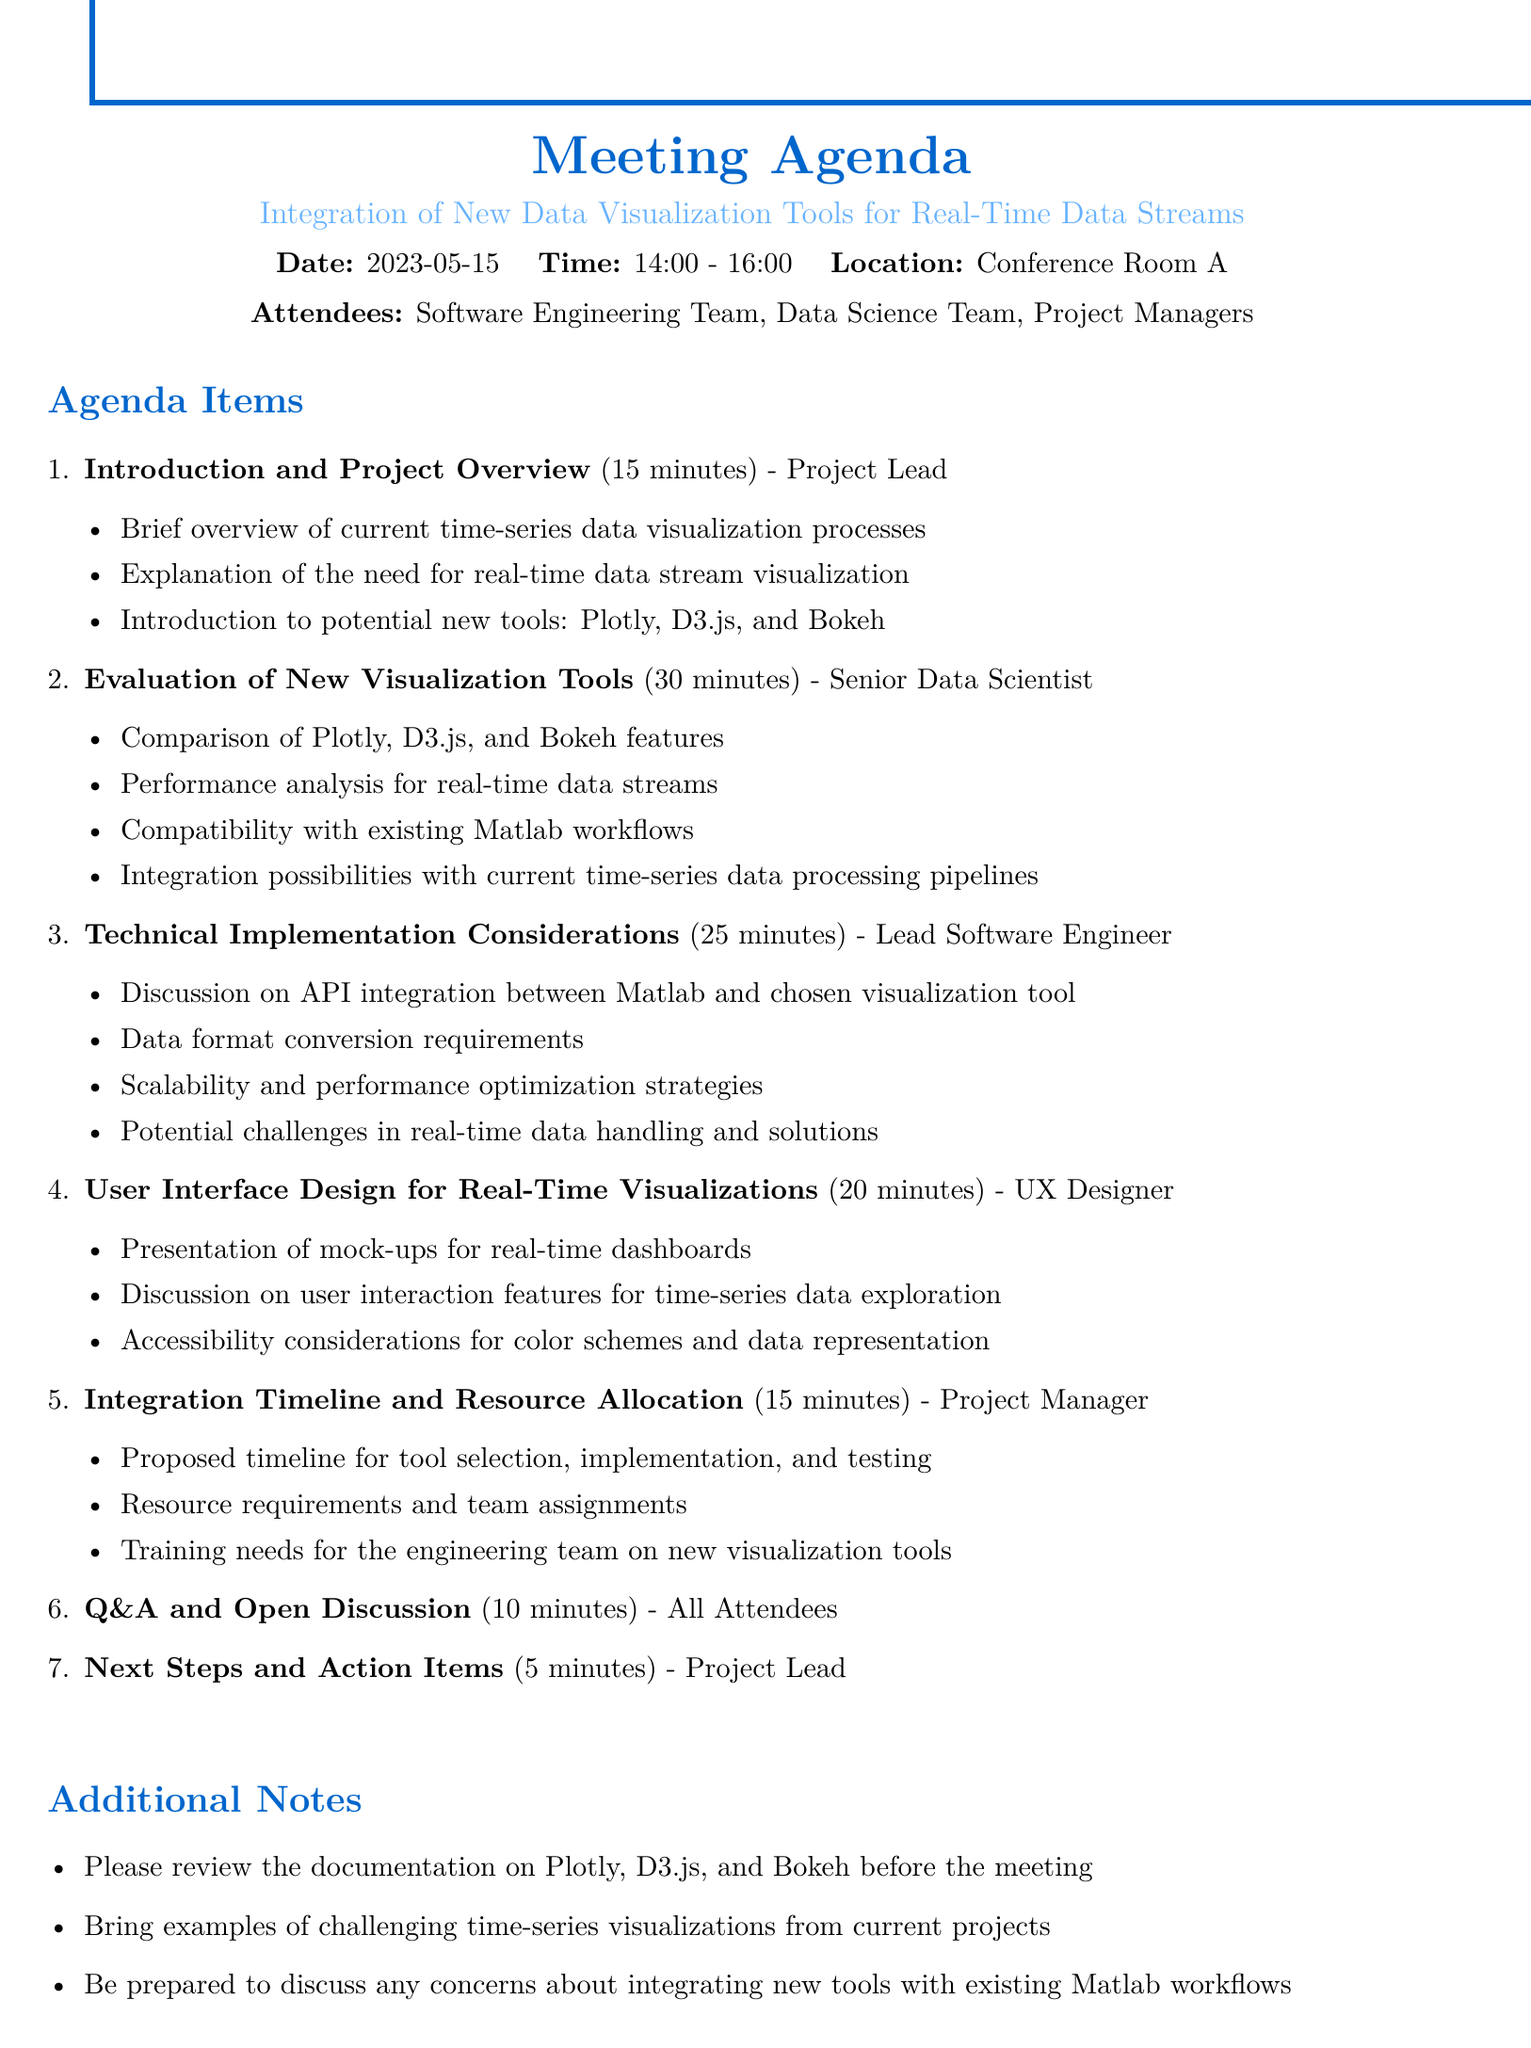What is the meeting date? The date of the meeting is specifically mentioned in the document as May 15, 2023.
Answer: May 15, 2023 Who is the presenter for the "Technical Implementation Considerations" topic? The document lists the presenter for the specific agenda item as the Lead Software Engineer.
Answer: Lead Software Engineer How long is the "Evaluation of New Visualization Tools" session? The duration for this session is indicated in the agenda, which is thirty minutes.
Answer: 30 minutes What is one of the proposed tools for real-time data stream visualization? The document includes potential tools, mentioning Plotly, D3.js, and Bokeh as examples.
Answer: Plotly What section discusses user interaction features? The section focused on user interaction features relates to the "User Interface Design for Real-Time Visualizations" agenda topic.
Answer: User Interface Design for Real-Time Visualizations What is the total duration allocated for Q&A and Open Discussion? The document specifies the time allocated for this part of the meeting as ten minutes.
Answer: 10 minutes Who is responsible for summarizing key decisions at the end of the meeting? The agenda outlines that the Project Lead will summarize key decisions and action items.
Answer: Project Lead What is required from attendees regarding new visualization tools? The additional notes state an expectation for attendees to review documentation on the new tools before the meeting.
Answer: Review documentation 